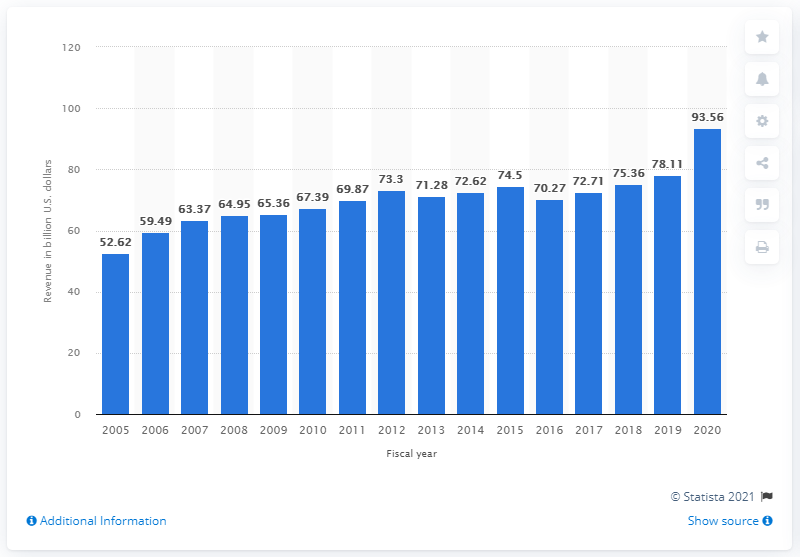Give some essential details in this illustration. In 2020, Target Corporation's revenue was 93.56. In 2015, Target's Canadian stores were closed. 